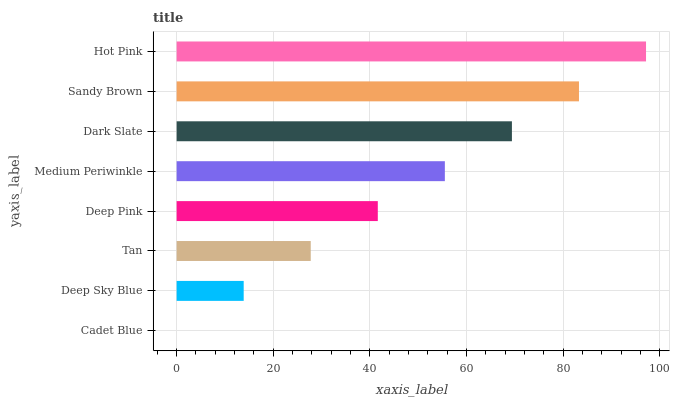Is Cadet Blue the minimum?
Answer yes or no. Yes. Is Hot Pink the maximum?
Answer yes or no. Yes. Is Deep Sky Blue the minimum?
Answer yes or no. No. Is Deep Sky Blue the maximum?
Answer yes or no. No. Is Deep Sky Blue greater than Cadet Blue?
Answer yes or no. Yes. Is Cadet Blue less than Deep Sky Blue?
Answer yes or no. Yes. Is Cadet Blue greater than Deep Sky Blue?
Answer yes or no. No. Is Deep Sky Blue less than Cadet Blue?
Answer yes or no. No. Is Medium Periwinkle the high median?
Answer yes or no. Yes. Is Deep Pink the low median?
Answer yes or no. Yes. Is Tan the high median?
Answer yes or no. No. Is Sandy Brown the low median?
Answer yes or no. No. 